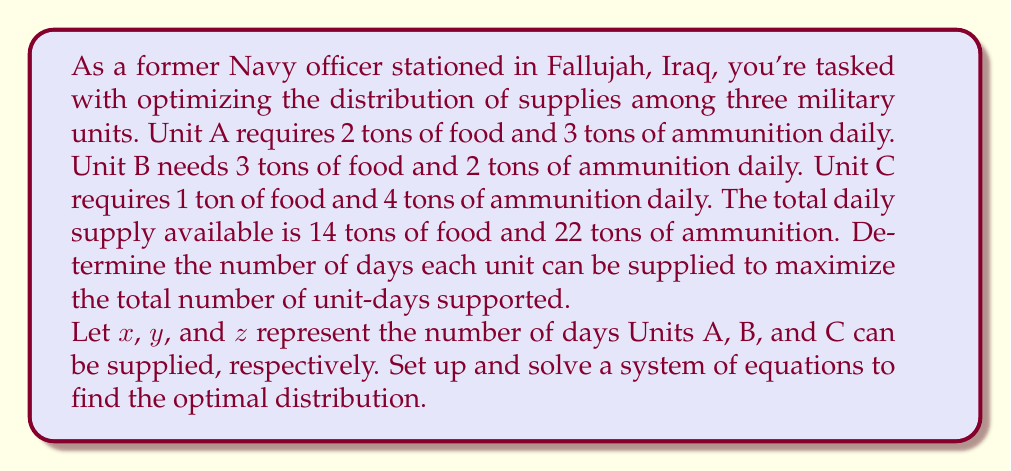Teach me how to tackle this problem. Let's approach this step-by-step:

1) First, let's set up the system of equations based on the given information:

   For food: $2x + 3y + z = 14$
   For ammunition: $3x + 2y + 4z = 22$

2) We want to maximize the total number of unit-days, which is represented by $x + y + z$.

3) This is a linear programming problem. We can solve it using the simplex method, but for this intermediate algebra problem, we'll use substitution and elimination.

4) From the first equation, we can express $z$ in terms of $x$ and $y$:
   $z = 14 - 2x - 3y$

5) Substitute this into the second equation:
   $3x + 2y + 4(14 - 2x - 3y) = 22$

6) Simplify:
   $3x + 2y + 56 - 8x - 12y = 22$
   $-5x - 10y = -34$
   $5x + 10y = 34$

7) Divide both sides by 5:
   $x + 2y = \frac{34}{5}$

8) Now we have two equations:
   $x + 2y = \frac{34}{5}$
   $2x + 3y = 14$

9) Multiply the first equation by 2 and subtract from the second:
   $2x + 4y = \frac{68}{5}$
   $2x + 3y = 14$
   Subtracting: $y = 14 - \frac{68}{5} = \frac{2}{5}$

10) Substitute this value of $y$ back into $x + 2y = \frac{34}{5}$:
    $x + 2(\frac{2}{5}) = \frac{34}{5}$
    $x = \frac{34}{5} - \frac{4}{5} = 6$

11) Now we can find $z$ using the equation from step 4:
    $z = 14 - 2(6) - 3(\frac{2}{5}) = 14 - 12 - \frac{6}{5} = \frac{8}{5}$

Therefore, the optimal distribution is:
Unit A: 6 days
Unit B: $\frac{2}{5}$ days
Unit C: $\frac{8}{5}$ days

The maximum total number of unit-days is $6 + \frac{2}{5} + \frac{8}{5} = 8$ days.
Answer: Unit A: 6 days
Unit B: $\frac{2}{5}$ days
Unit C: $\frac{8}{5}$ days
Maximum total unit-days: 8 days 